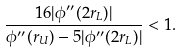Convert formula to latex. <formula><loc_0><loc_0><loc_500><loc_500>\frac { 1 6 | \phi ^ { \prime \prime } ( 2 r _ { L } ) | } { \phi ^ { \prime \prime } ( r _ { U } ) - 5 | \phi ^ { \prime \prime } ( 2 r _ { L } ) | } < 1 .</formula> 